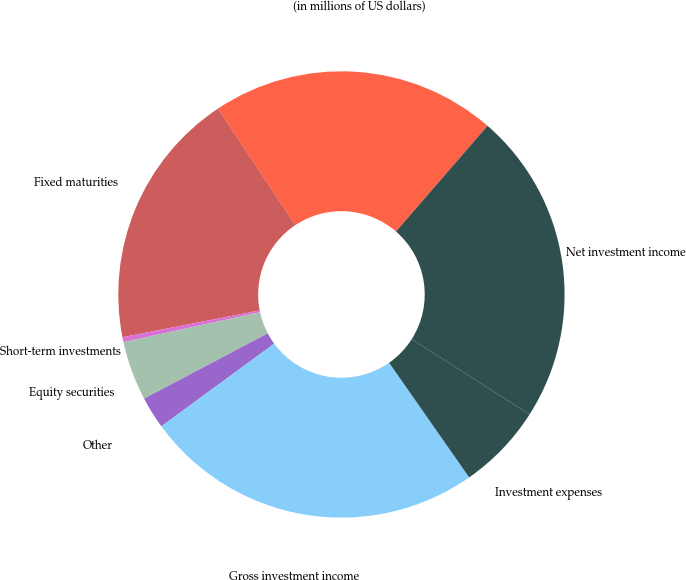<chart> <loc_0><loc_0><loc_500><loc_500><pie_chart><fcel>(in millions of US dollars)<fcel>Fixed maturities<fcel>Short-term investments<fcel>Equity securities<fcel>Other<fcel>Gross investment income<fcel>Investment expenses<fcel>Net investment income<nl><fcel>20.7%<fcel>18.73%<fcel>0.36%<fcel>4.3%<fcel>2.33%<fcel>24.64%<fcel>6.27%<fcel>22.67%<nl></chart> 